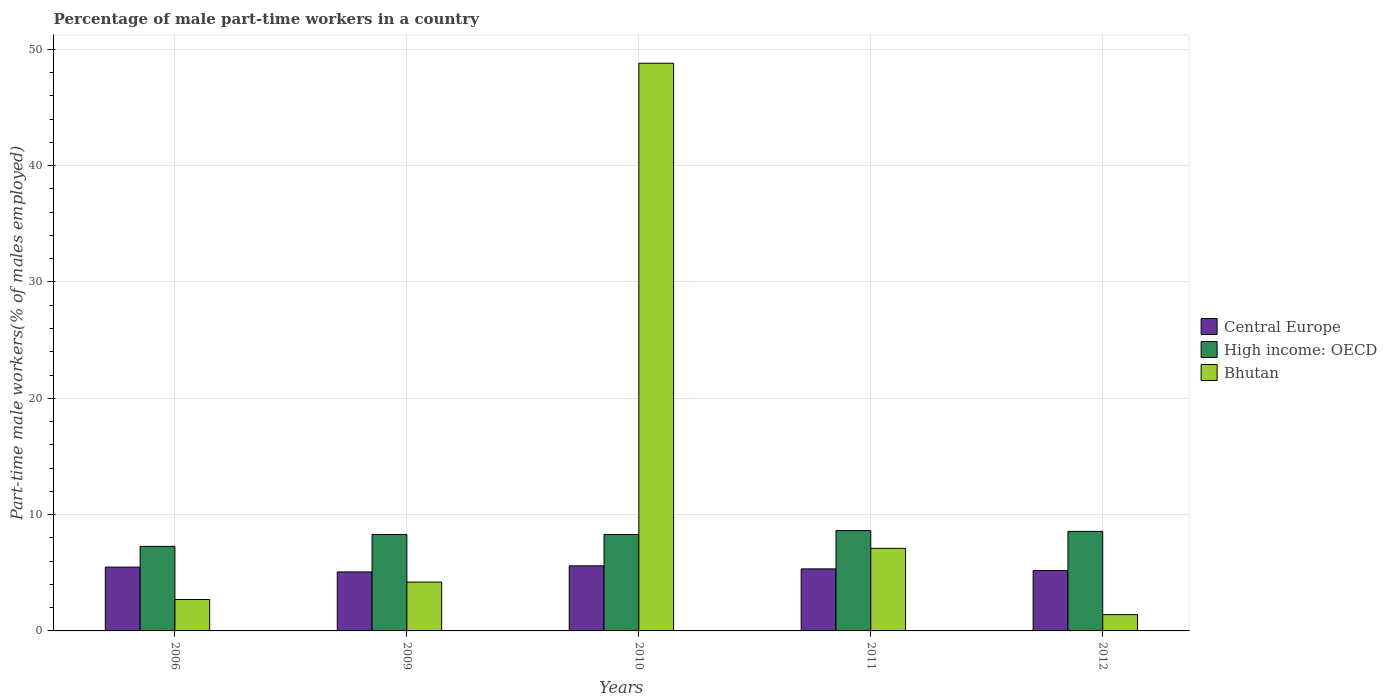How many different coloured bars are there?
Your response must be concise. 3. Are the number of bars per tick equal to the number of legend labels?
Your answer should be very brief. Yes. How many bars are there on the 2nd tick from the left?
Your answer should be compact. 3. In how many cases, is the number of bars for a given year not equal to the number of legend labels?
Offer a very short reply. 0. What is the percentage of male part-time workers in High income: OECD in 2010?
Your answer should be compact. 8.29. Across all years, what is the maximum percentage of male part-time workers in Central Europe?
Offer a terse response. 5.6. Across all years, what is the minimum percentage of male part-time workers in Bhutan?
Keep it short and to the point. 1.4. In which year was the percentage of male part-time workers in High income: OECD maximum?
Make the answer very short. 2011. What is the total percentage of male part-time workers in Bhutan in the graph?
Offer a terse response. 64.2. What is the difference between the percentage of male part-time workers in High income: OECD in 2011 and that in 2012?
Your answer should be compact. 0.07. What is the difference between the percentage of male part-time workers in High income: OECD in 2011 and the percentage of male part-time workers in Bhutan in 2012?
Make the answer very short. 7.22. What is the average percentage of male part-time workers in Central Europe per year?
Your answer should be compact. 5.34. In the year 2009, what is the difference between the percentage of male part-time workers in Bhutan and percentage of male part-time workers in High income: OECD?
Provide a succinct answer. -4.09. What is the ratio of the percentage of male part-time workers in Bhutan in 2011 to that in 2012?
Give a very brief answer. 5.07. Is the percentage of male part-time workers in High income: OECD in 2006 less than that in 2011?
Keep it short and to the point. Yes. Is the difference between the percentage of male part-time workers in Bhutan in 2009 and 2010 greater than the difference between the percentage of male part-time workers in High income: OECD in 2009 and 2010?
Offer a terse response. No. What is the difference between the highest and the second highest percentage of male part-time workers in Bhutan?
Give a very brief answer. 41.7. What is the difference between the highest and the lowest percentage of male part-time workers in Central Europe?
Your answer should be compact. 0.52. In how many years, is the percentage of male part-time workers in Central Europe greater than the average percentage of male part-time workers in Central Europe taken over all years?
Offer a very short reply. 2. Is the sum of the percentage of male part-time workers in High income: OECD in 2006 and 2011 greater than the maximum percentage of male part-time workers in Central Europe across all years?
Offer a very short reply. Yes. What does the 3rd bar from the left in 2009 represents?
Your answer should be compact. Bhutan. What does the 3rd bar from the right in 2011 represents?
Ensure brevity in your answer.  Central Europe. Are all the bars in the graph horizontal?
Give a very brief answer. No. Are the values on the major ticks of Y-axis written in scientific E-notation?
Your response must be concise. No. Does the graph contain any zero values?
Provide a succinct answer. No. Does the graph contain grids?
Ensure brevity in your answer.  Yes. How many legend labels are there?
Ensure brevity in your answer.  3. What is the title of the graph?
Your answer should be very brief. Percentage of male part-time workers in a country. Does "St. Lucia" appear as one of the legend labels in the graph?
Keep it short and to the point. No. What is the label or title of the X-axis?
Make the answer very short. Years. What is the label or title of the Y-axis?
Give a very brief answer. Part-time male workers(% of males employed). What is the Part-time male workers(% of males employed) in Central Europe in 2006?
Ensure brevity in your answer.  5.49. What is the Part-time male workers(% of males employed) of High income: OECD in 2006?
Provide a succinct answer. 7.27. What is the Part-time male workers(% of males employed) in Bhutan in 2006?
Your answer should be compact. 2.7. What is the Part-time male workers(% of males employed) of Central Europe in 2009?
Your answer should be very brief. 5.07. What is the Part-time male workers(% of males employed) of High income: OECD in 2009?
Provide a short and direct response. 8.29. What is the Part-time male workers(% of males employed) of Bhutan in 2009?
Provide a short and direct response. 4.2. What is the Part-time male workers(% of males employed) of Central Europe in 2010?
Keep it short and to the point. 5.6. What is the Part-time male workers(% of males employed) of High income: OECD in 2010?
Make the answer very short. 8.29. What is the Part-time male workers(% of males employed) in Bhutan in 2010?
Provide a short and direct response. 48.8. What is the Part-time male workers(% of males employed) of Central Europe in 2011?
Your answer should be very brief. 5.33. What is the Part-time male workers(% of males employed) of High income: OECD in 2011?
Ensure brevity in your answer.  8.62. What is the Part-time male workers(% of males employed) of Bhutan in 2011?
Keep it short and to the point. 7.1. What is the Part-time male workers(% of males employed) in Central Europe in 2012?
Your response must be concise. 5.19. What is the Part-time male workers(% of males employed) of High income: OECD in 2012?
Give a very brief answer. 8.56. What is the Part-time male workers(% of males employed) of Bhutan in 2012?
Ensure brevity in your answer.  1.4. Across all years, what is the maximum Part-time male workers(% of males employed) of Central Europe?
Make the answer very short. 5.6. Across all years, what is the maximum Part-time male workers(% of males employed) of High income: OECD?
Your response must be concise. 8.62. Across all years, what is the maximum Part-time male workers(% of males employed) in Bhutan?
Your response must be concise. 48.8. Across all years, what is the minimum Part-time male workers(% of males employed) in Central Europe?
Offer a terse response. 5.07. Across all years, what is the minimum Part-time male workers(% of males employed) of High income: OECD?
Provide a succinct answer. 7.27. Across all years, what is the minimum Part-time male workers(% of males employed) in Bhutan?
Your answer should be compact. 1.4. What is the total Part-time male workers(% of males employed) of Central Europe in the graph?
Your answer should be very brief. 26.68. What is the total Part-time male workers(% of males employed) in High income: OECD in the graph?
Offer a terse response. 41.03. What is the total Part-time male workers(% of males employed) in Bhutan in the graph?
Provide a short and direct response. 64.2. What is the difference between the Part-time male workers(% of males employed) of Central Europe in 2006 and that in 2009?
Give a very brief answer. 0.41. What is the difference between the Part-time male workers(% of males employed) in High income: OECD in 2006 and that in 2009?
Give a very brief answer. -1.03. What is the difference between the Part-time male workers(% of males employed) in Bhutan in 2006 and that in 2009?
Offer a terse response. -1.5. What is the difference between the Part-time male workers(% of males employed) in Central Europe in 2006 and that in 2010?
Give a very brief answer. -0.11. What is the difference between the Part-time male workers(% of males employed) of High income: OECD in 2006 and that in 2010?
Your answer should be compact. -1.02. What is the difference between the Part-time male workers(% of males employed) of Bhutan in 2006 and that in 2010?
Offer a terse response. -46.1. What is the difference between the Part-time male workers(% of males employed) in Central Europe in 2006 and that in 2011?
Offer a very short reply. 0.15. What is the difference between the Part-time male workers(% of males employed) of High income: OECD in 2006 and that in 2011?
Ensure brevity in your answer.  -1.36. What is the difference between the Part-time male workers(% of males employed) of Bhutan in 2006 and that in 2011?
Your response must be concise. -4.4. What is the difference between the Part-time male workers(% of males employed) in Central Europe in 2006 and that in 2012?
Provide a succinct answer. 0.29. What is the difference between the Part-time male workers(% of males employed) of High income: OECD in 2006 and that in 2012?
Provide a short and direct response. -1.29. What is the difference between the Part-time male workers(% of males employed) in Central Europe in 2009 and that in 2010?
Give a very brief answer. -0.52. What is the difference between the Part-time male workers(% of males employed) in High income: OECD in 2009 and that in 2010?
Make the answer very short. 0. What is the difference between the Part-time male workers(% of males employed) of Bhutan in 2009 and that in 2010?
Your response must be concise. -44.6. What is the difference between the Part-time male workers(% of males employed) of Central Europe in 2009 and that in 2011?
Provide a succinct answer. -0.26. What is the difference between the Part-time male workers(% of males employed) in High income: OECD in 2009 and that in 2011?
Make the answer very short. -0.33. What is the difference between the Part-time male workers(% of males employed) in Bhutan in 2009 and that in 2011?
Provide a short and direct response. -2.9. What is the difference between the Part-time male workers(% of males employed) in Central Europe in 2009 and that in 2012?
Your answer should be compact. -0.12. What is the difference between the Part-time male workers(% of males employed) in High income: OECD in 2009 and that in 2012?
Offer a very short reply. -0.26. What is the difference between the Part-time male workers(% of males employed) of Bhutan in 2009 and that in 2012?
Offer a terse response. 2.8. What is the difference between the Part-time male workers(% of males employed) in Central Europe in 2010 and that in 2011?
Offer a terse response. 0.26. What is the difference between the Part-time male workers(% of males employed) in High income: OECD in 2010 and that in 2011?
Keep it short and to the point. -0.33. What is the difference between the Part-time male workers(% of males employed) of Bhutan in 2010 and that in 2011?
Offer a very short reply. 41.7. What is the difference between the Part-time male workers(% of males employed) in Central Europe in 2010 and that in 2012?
Provide a succinct answer. 0.4. What is the difference between the Part-time male workers(% of males employed) in High income: OECD in 2010 and that in 2012?
Ensure brevity in your answer.  -0.27. What is the difference between the Part-time male workers(% of males employed) of Bhutan in 2010 and that in 2012?
Provide a succinct answer. 47.4. What is the difference between the Part-time male workers(% of males employed) in Central Europe in 2011 and that in 2012?
Provide a short and direct response. 0.14. What is the difference between the Part-time male workers(% of males employed) of High income: OECD in 2011 and that in 2012?
Your answer should be very brief. 0.07. What is the difference between the Part-time male workers(% of males employed) of Central Europe in 2006 and the Part-time male workers(% of males employed) of High income: OECD in 2009?
Provide a succinct answer. -2.81. What is the difference between the Part-time male workers(% of males employed) in Central Europe in 2006 and the Part-time male workers(% of males employed) in Bhutan in 2009?
Offer a terse response. 1.28. What is the difference between the Part-time male workers(% of males employed) of High income: OECD in 2006 and the Part-time male workers(% of males employed) of Bhutan in 2009?
Make the answer very short. 3.07. What is the difference between the Part-time male workers(% of males employed) of Central Europe in 2006 and the Part-time male workers(% of males employed) of High income: OECD in 2010?
Your answer should be very brief. -2.81. What is the difference between the Part-time male workers(% of males employed) in Central Europe in 2006 and the Part-time male workers(% of males employed) in Bhutan in 2010?
Offer a very short reply. -43.31. What is the difference between the Part-time male workers(% of males employed) in High income: OECD in 2006 and the Part-time male workers(% of males employed) in Bhutan in 2010?
Provide a succinct answer. -41.53. What is the difference between the Part-time male workers(% of males employed) of Central Europe in 2006 and the Part-time male workers(% of males employed) of High income: OECD in 2011?
Your answer should be very brief. -3.14. What is the difference between the Part-time male workers(% of males employed) in Central Europe in 2006 and the Part-time male workers(% of males employed) in Bhutan in 2011?
Offer a very short reply. -1.61. What is the difference between the Part-time male workers(% of males employed) in High income: OECD in 2006 and the Part-time male workers(% of males employed) in Bhutan in 2011?
Make the answer very short. 0.17. What is the difference between the Part-time male workers(% of males employed) in Central Europe in 2006 and the Part-time male workers(% of males employed) in High income: OECD in 2012?
Your answer should be very brief. -3.07. What is the difference between the Part-time male workers(% of males employed) in Central Europe in 2006 and the Part-time male workers(% of males employed) in Bhutan in 2012?
Offer a terse response. 4.08. What is the difference between the Part-time male workers(% of males employed) in High income: OECD in 2006 and the Part-time male workers(% of males employed) in Bhutan in 2012?
Your answer should be very brief. 5.87. What is the difference between the Part-time male workers(% of males employed) of Central Europe in 2009 and the Part-time male workers(% of males employed) of High income: OECD in 2010?
Ensure brevity in your answer.  -3.22. What is the difference between the Part-time male workers(% of males employed) in Central Europe in 2009 and the Part-time male workers(% of males employed) in Bhutan in 2010?
Keep it short and to the point. -43.73. What is the difference between the Part-time male workers(% of males employed) of High income: OECD in 2009 and the Part-time male workers(% of males employed) of Bhutan in 2010?
Your response must be concise. -40.51. What is the difference between the Part-time male workers(% of males employed) in Central Europe in 2009 and the Part-time male workers(% of males employed) in High income: OECD in 2011?
Keep it short and to the point. -3.55. What is the difference between the Part-time male workers(% of males employed) in Central Europe in 2009 and the Part-time male workers(% of males employed) in Bhutan in 2011?
Give a very brief answer. -2.03. What is the difference between the Part-time male workers(% of males employed) in High income: OECD in 2009 and the Part-time male workers(% of males employed) in Bhutan in 2011?
Your answer should be compact. 1.19. What is the difference between the Part-time male workers(% of males employed) in Central Europe in 2009 and the Part-time male workers(% of males employed) in High income: OECD in 2012?
Provide a short and direct response. -3.48. What is the difference between the Part-time male workers(% of males employed) of Central Europe in 2009 and the Part-time male workers(% of males employed) of Bhutan in 2012?
Your answer should be very brief. 3.67. What is the difference between the Part-time male workers(% of males employed) in High income: OECD in 2009 and the Part-time male workers(% of males employed) in Bhutan in 2012?
Your answer should be very brief. 6.89. What is the difference between the Part-time male workers(% of males employed) in Central Europe in 2010 and the Part-time male workers(% of males employed) in High income: OECD in 2011?
Make the answer very short. -3.03. What is the difference between the Part-time male workers(% of males employed) in Central Europe in 2010 and the Part-time male workers(% of males employed) in Bhutan in 2011?
Your response must be concise. -1.5. What is the difference between the Part-time male workers(% of males employed) of High income: OECD in 2010 and the Part-time male workers(% of males employed) of Bhutan in 2011?
Your response must be concise. 1.19. What is the difference between the Part-time male workers(% of males employed) of Central Europe in 2010 and the Part-time male workers(% of males employed) of High income: OECD in 2012?
Keep it short and to the point. -2.96. What is the difference between the Part-time male workers(% of males employed) in Central Europe in 2010 and the Part-time male workers(% of males employed) in Bhutan in 2012?
Give a very brief answer. 4.2. What is the difference between the Part-time male workers(% of males employed) of High income: OECD in 2010 and the Part-time male workers(% of males employed) of Bhutan in 2012?
Offer a very short reply. 6.89. What is the difference between the Part-time male workers(% of males employed) in Central Europe in 2011 and the Part-time male workers(% of males employed) in High income: OECD in 2012?
Offer a terse response. -3.22. What is the difference between the Part-time male workers(% of males employed) of Central Europe in 2011 and the Part-time male workers(% of males employed) of Bhutan in 2012?
Make the answer very short. 3.93. What is the difference between the Part-time male workers(% of males employed) of High income: OECD in 2011 and the Part-time male workers(% of males employed) of Bhutan in 2012?
Offer a terse response. 7.22. What is the average Part-time male workers(% of males employed) of Central Europe per year?
Offer a terse response. 5.34. What is the average Part-time male workers(% of males employed) in High income: OECD per year?
Give a very brief answer. 8.21. What is the average Part-time male workers(% of males employed) in Bhutan per year?
Give a very brief answer. 12.84. In the year 2006, what is the difference between the Part-time male workers(% of males employed) in Central Europe and Part-time male workers(% of males employed) in High income: OECD?
Offer a very short reply. -1.78. In the year 2006, what is the difference between the Part-time male workers(% of males employed) in Central Europe and Part-time male workers(% of males employed) in Bhutan?
Your response must be concise. 2.79. In the year 2006, what is the difference between the Part-time male workers(% of males employed) in High income: OECD and Part-time male workers(% of males employed) in Bhutan?
Provide a short and direct response. 4.57. In the year 2009, what is the difference between the Part-time male workers(% of males employed) of Central Europe and Part-time male workers(% of males employed) of High income: OECD?
Your answer should be very brief. -3.22. In the year 2009, what is the difference between the Part-time male workers(% of males employed) in Central Europe and Part-time male workers(% of males employed) in Bhutan?
Provide a succinct answer. 0.87. In the year 2009, what is the difference between the Part-time male workers(% of males employed) of High income: OECD and Part-time male workers(% of males employed) of Bhutan?
Offer a terse response. 4.09. In the year 2010, what is the difference between the Part-time male workers(% of males employed) in Central Europe and Part-time male workers(% of males employed) in High income: OECD?
Give a very brief answer. -2.7. In the year 2010, what is the difference between the Part-time male workers(% of males employed) in Central Europe and Part-time male workers(% of males employed) in Bhutan?
Your answer should be compact. -43.2. In the year 2010, what is the difference between the Part-time male workers(% of males employed) of High income: OECD and Part-time male workers(% of males employed) of Bhutan?
Give a very brief answer. -40.51. In the year 2011, what is the difference between the Part-time male workers(% of males employed) in Central Europe and Part-time male workers(% of males employed) in High income: OECD?
Make the answer very short. -3.29. In the year 2011, what is the difference between the Part-time male workers(% of males employed) of Central Europe and Part-time male workers(% of males employed) of Bhutan?
Make the answer very short. -1.77. In the year 2011, what is the difference between the Part-time male workers(% of males employed) of High income: OECD and Part-time male workers(% of males employed) of Bhutan?
Your response must be concise. 1.52. In the year 2012, what is the difference between the Part-time male workers(% of males employed) in Central Europe and Part-time male workers(% of males employed) in High income: OECD?
Your answer should be compact. -3.37. In the year 2012, what is the difference between the Part-time male workers(% of males employed) in Central Europe and Part-time male workers(% of males employed) in Bhutan?
Offer a very short reply. 3.79. In the year 2012, what is the difference between the Part-time male workers(% of males employed) in High income: OECD and Part-time male workers(% of males employed) in Bhutan?
Your response must be concise. 7.16. What is the ratio of the Part-time male workers(% of males employed) in Central Europe in 2006 to that in 2009?
Keep it short and to the point. 1.08. What is the ratio of the Part-time male workers(% of males employed) of High income: OECD in 2006 to that in 2009?
Ensure brevity in your answer.  0.88. What is the ratio of the Part-time male workers(% of males employed) of Bhutan in 2006 to that in 2009?
Provide a succinct answer. 0.64. What is the ratio of the Part-time male workers(% of males employed) of Central Europe in 2006 to that in 2010?
Offer a terse response. 0.98. What is the ratio of the Part-time male workers(% of males employed) of High income: OECD in 2006 to that in 2010?
Your answer should be compact. 0.88. What is the ratio of the Part-time male workers(% of males employed) of Bhutan in 2006 to that in 2010?
Make the answer very short. 0.06. What is the ratio of the Part-time male workers(% of males employed) of Central Europe in 2006 to that in 2011?
Keep it short and to the point. 1.03. What is the ratio of the Part-time male workers(% of males employed) in High income: OECD in 2006 to that in 2011?
Keep it short and to the point. 0.84. What is the ratio of the Part-time male workers(% of males employed) in Bhutan in 2006 to that in 2011?
Your answer should be compact. 0.38. What is the ratio of the Part-time male workers(% of males employed) of Central Europe in 2006 to that in 2012?
Offer a very short reply. 1.06. What is the ratio of the Part-time male workers(% of males employed) in High income: OECD in 2006 to that in 2012?
Provide a succinct answer. 0.85. What is the ratio of the Part-time male workers(% of males employed) of Bhutan in 2006 to that in 2012?
Offer a very short reply. 1.93. What is the ratio of the Part-time male workers(% of males employed) in Central Europe in 2009 to that in 2010?
Keep it short and to the point. 0.91. What is the ratio of the Part-time male workers(% of males employed) of Bhutan in 2009 to that in 2010?
Your answer should be compact. 0.09. What is the ratio of the Part-time male workers(% of males employed) in Central Europe in 2009 to that in 2011?
Your response must be concise. 0.95. What is the ratio of the Part-time male workers(% of males employed) in High income: OECD in 2009 to that in 2011?
Provide a succinct answer. 0.96. What is the ratio of the Part-time male workers(% of males employed) of Bhutan in 2009 to that in 2011?
Ensure brevity in your answer.  0.59. What is the ratio of the Part-time male workers(% of males employed) of Central Europe in 2009 to that in 2012?
Offer a terse response. 0.98. What is the ratio of the Part-time male workers(% of males employed) in High income: OECD in 2009 to that in 2012?
Ensure brevity in your answer.  0.97. What is the ratio of the Part-time male workers(% of males employed) in Central Europe in 2010 to that in 2011?
Make the answer very short. 1.05. What is the ratio of the Part-time male workers(% of males employed) in High income: OECD in 2010 to that in 2011?
Ensure brevity in your answer.  0.96. What is the ratio of the Part-time male workers(% of males employed) of Bhutan in 2010 to that in 2011?
Your response must be concise. 6.87. What is the ratio of the Part-time male workers(% of males employed) of Central Europe in 2010 to that in 2012?
Offer a very short reply. 1.08. What is the ratio of the Part-time male workers(% of males employed) in Bhutan in 2010 to that in 2012?
Your response must be concise. 34.86. What is the ratio of the Part-time male workers(% of males employed) of Central Europe in 2011 to that in 2012?
Keep it short and to the point. 1.03. What is the ratio of the Part-time male workers(% of males employed) in High income: OECD in 2011 to that in 2012?
Your answer should be compact. 1.01. What is the ratio of the Part-time male workers(% of males employed) in Bhutan in 2011 to that in 2012?
Offer a very short reply. 5.07. What is the difference between the highest and the second highest Part-time male workers(% of males employed) of Central Europe?
Keep it short and to the point. 0.11. What is the difference between the highest and the second highest Part-time male workers(% of males employed) of High income: OECD?
Your response must be concise. 0.07. What is the difference between the highest and the second highest Part-time male workers(% of males employed) in Bhutan?
Your response must be concise. 41.7. What is the difference between the highest and the lowest Part-time male workers(% of males employed) in Central Europe?
Offer a terse response. 0.52. What is the difference between the highest and the lowest Part-time male workers(% of males employed) of High income: OECD?
Your answer should be very brief. 1.36. What is the difference between the highest and the lowest Part-time male workers(% of males employed) of Bhutan?
Your response must be concise. 47.4. 